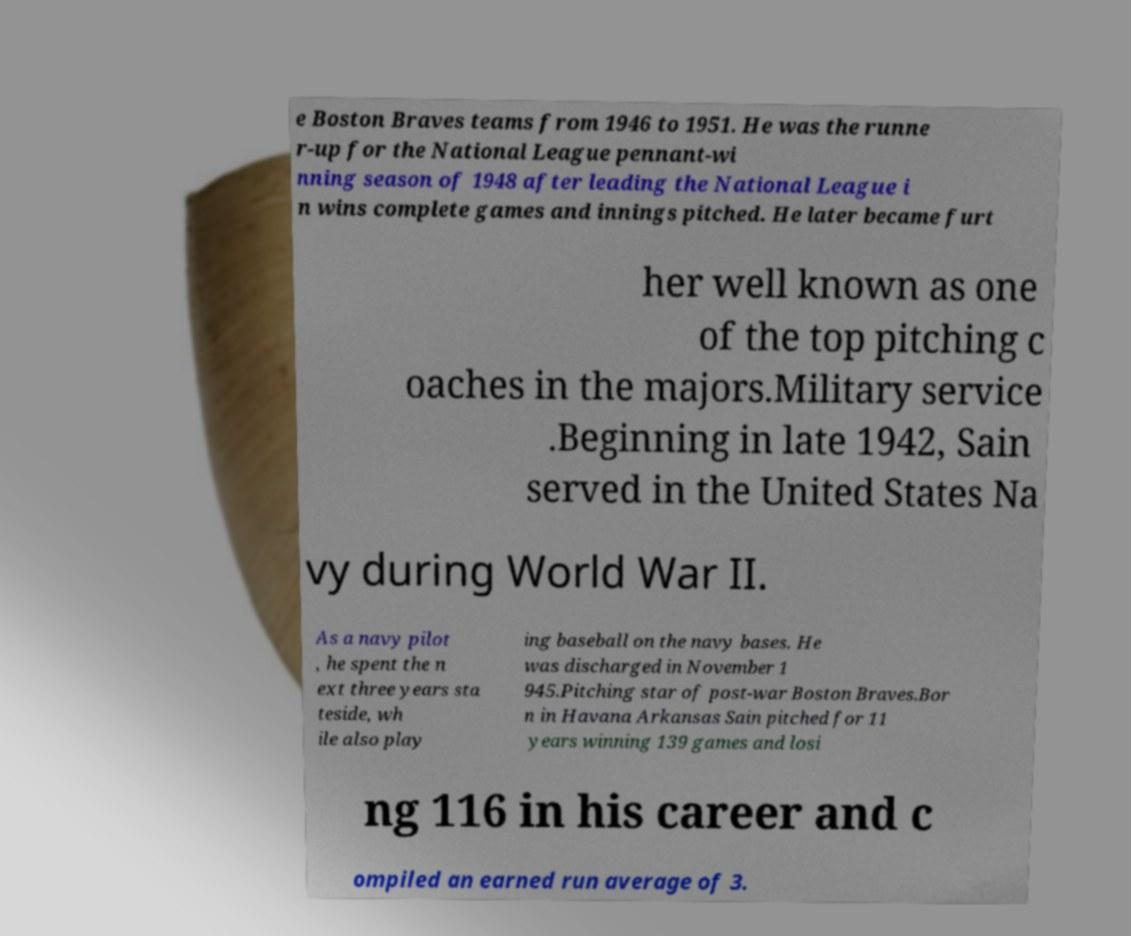What messages or text are displayed in this image? I need them in a readable, typed format. e Boston Braves teams from 1946 to 1951. He was the runne r-up for the National League pennant-wi nning season of 1948 after leading the National League i n wins complete games and innings pitched. He later became furt her well known as one of the top pitching c oaches in the majors.Military service .Beginning in late 1942, Sain served in the United States Na vy during World War II. As a navy pilot , he spent the n ext three years sta teside, wh ile also play ing baseball on the navy bases. He was discharged in November 1 945.Pitching star of post-war Boston Braves.Bor n in Havana Arkansas Sain pitched for 11 years winning 139 games and losi ng 116 in his career and c ompiled an earned run average of 3. 